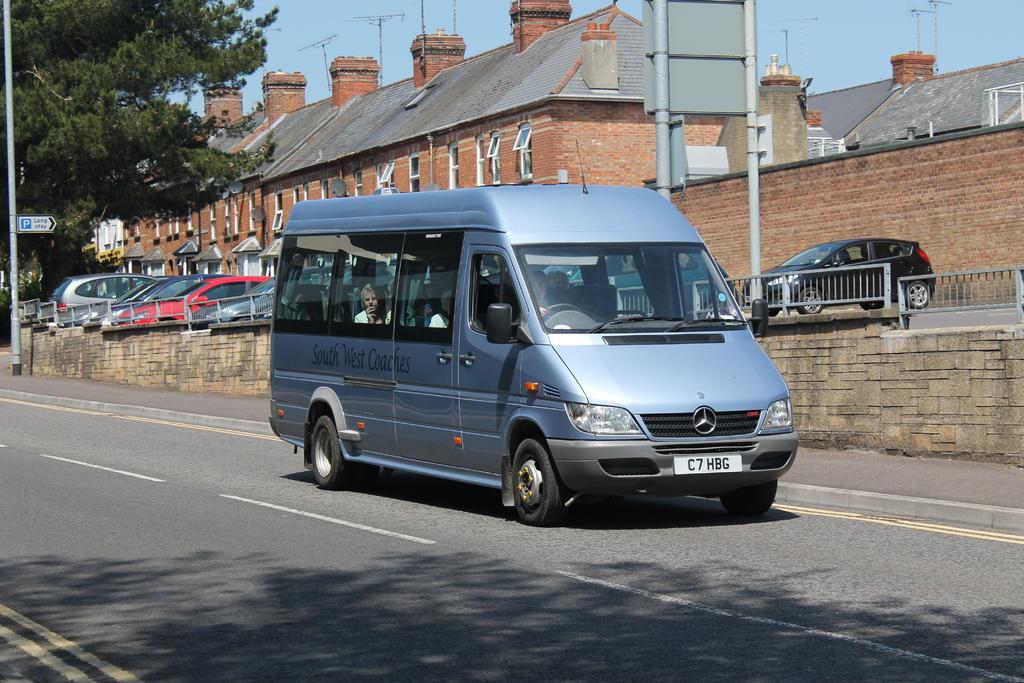What is written on this van?
Make the answer very short. South west coaches. What does the license plate say?
Offer a terse response. C7 hbg. 